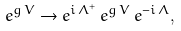Convert formula to latex. <formula><loc_0><loc_0><loc_500><loc_500>e ^ { g \, V } \rightarrow e ^ { i \, \Lambda ^ { + } } \, e ^ { g \, V } \, e ^ { - i \, \Lambda } ,</formula> 